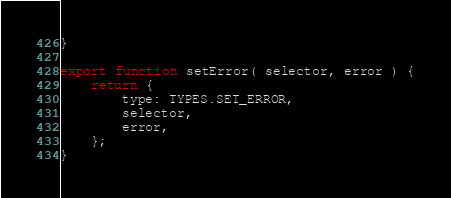Convert code to text. <code><loc_0><loc_0><loc_500><loc_500><_JavaScript_>}

export function setError( selector, error ) {
	return {
		type: TYPES.SET_ERROR,
		selector,
		error,
	};
}
</code> 